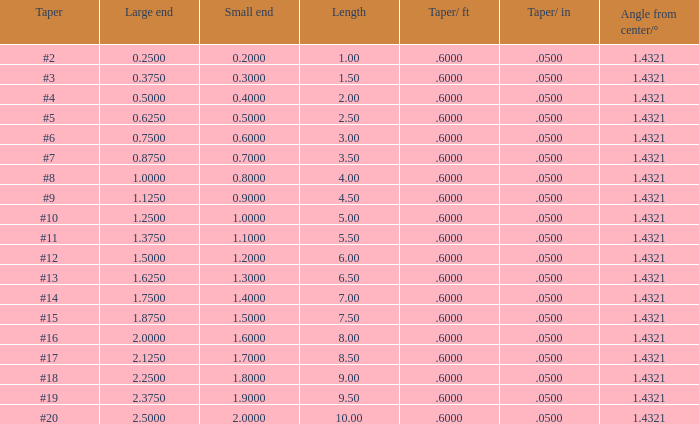Parse the table in full. {'header': ['Taper', 'Large end', 'Small end', 'Length', 'Taper/ ft', 'Taper/ in', 'Angle from center/°'], 'rows': [['#2', '0.2500', '0.2000', '1.00', '.6000', '.0500', '1.4321'], ['#3', '0.3750', '0.3000', '1.50', '.6000', '.0500', '1.4321'], ['#4', '0.5000', '0.4000', '2.00', '.6000', '.0500', '1.4321'], ['#5', '0.6250', '0.5000', '2.50', '.6000', '.0500', '1.4321'], ['#6', '0.7500', '0.6000', '3.00', '.6000', '.0500', '1.4321'], ['#7', '0.8750', '0.7000', '3.50', '.6000', '.0500', '1.4321'], ['#8', '1.0000', '0.8000', '4.00', '.6000', '.0500', '1.4321'], ['#9', '1.1250', '0.9000', '4.50', '.6000', '.0500', '1.4321'], ['#10', '1.2500', '1.0000', '5.00', '.6000', '.0500', '1.4321'], ['#11', '1.3750', '1.1000', '5.50', '.6000', '.0500', '1.4321'], ['#12', '1.5000', '1.2000', '6.00', '.6000', '.0500', '1.4321'], ['#13', '1.6250', '1.3000', '6.50', '.6000', '.0500', '1.4321'], ['#14', '1.7500', '1.4000', '7.00', '.6000', '.0500', '1.4321'], ['#15', '1.8750', '1.5000', '7.50', '.6000', '.0500', '1.4321'], ['#16', '2.0000', '1.6000', '8.00', '.6000', '.0500', '1.4321'], ['#17', '2.1250', '1.7000', '8.50', '.6000', '.0500', '1.4321'], ['#18', '2.2500', '1.8000', '9.00', '.6000', '.0500', '1.4321'], ['#19', '2.3750', '1.9000', '9.50', '.6000', '.0500', '1.4321'], ['#20', '2.5000', '2.0000', '10.00', '.6000', '.0500', '1.4321']]} 6000000000000001? 19.0. 